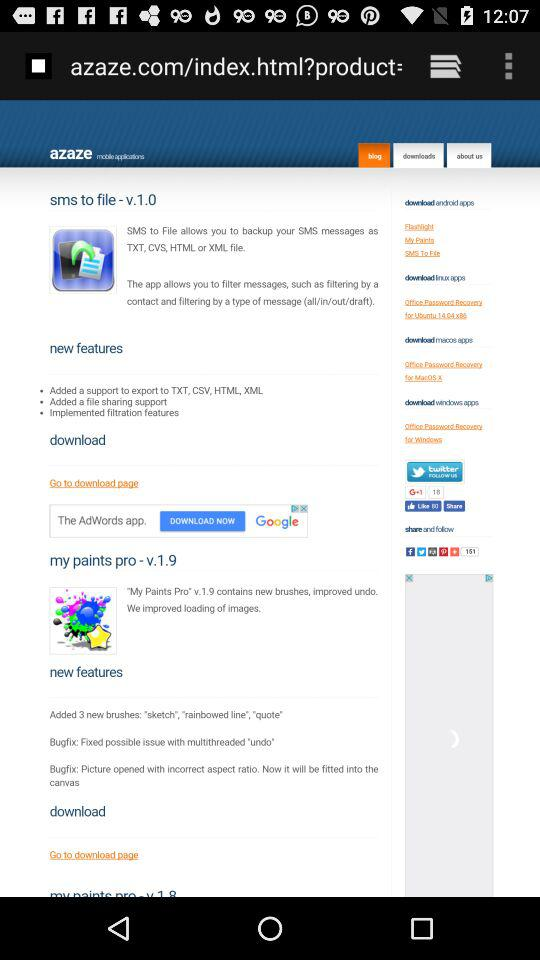What is the version of the application "sms to file"? The version of the application "sms to file" is v.1.0. 